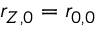Convert formula to latex. <formula><loc_0><loc_0><loc_500><loc_500>r _ { Z , 0 } = r _ { 0 , 0 }</formula> 